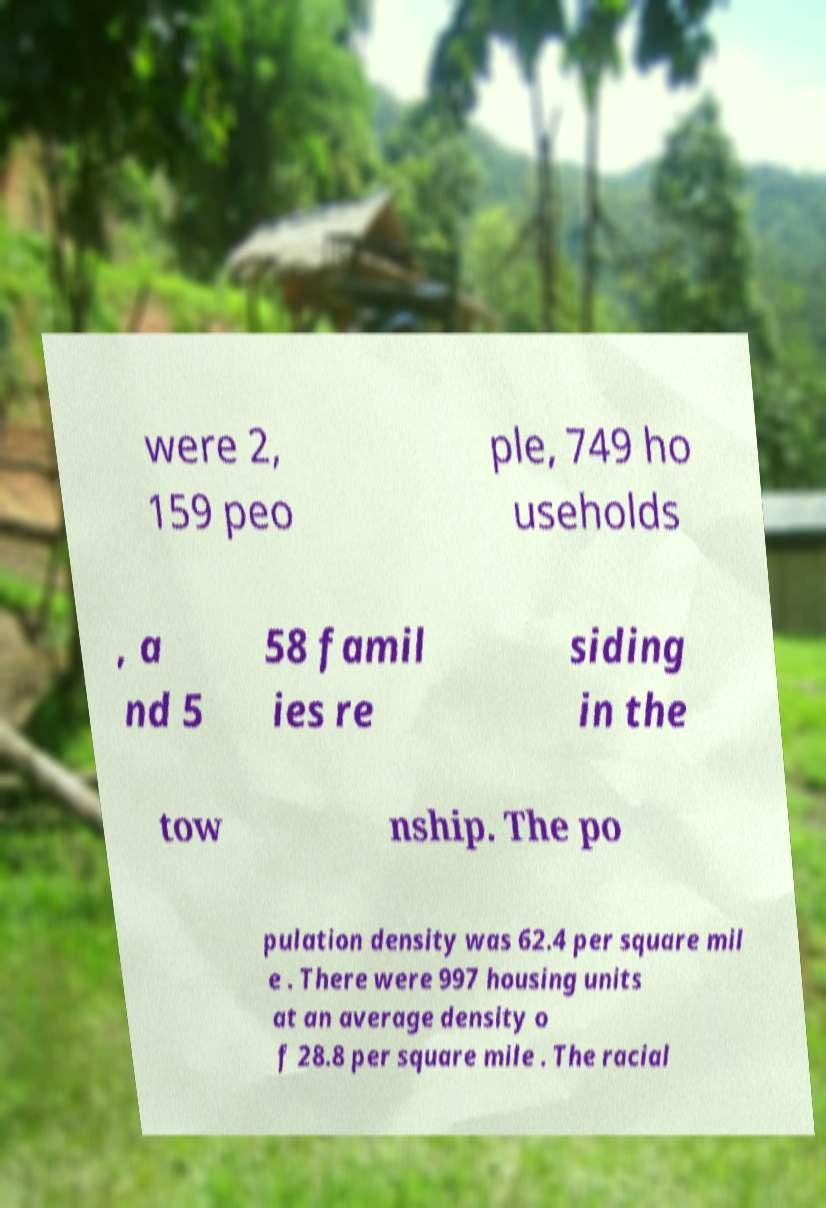Could you extract and type out the text from this image? were 2, 159 peo ple, 749 ho useholds , a nd 5 58 famil ies re siding in the tow nship. The po pulation density was 62.4 per square mil e . There were 997 housing units at an average density o f 28.8 per square mile . The racial 